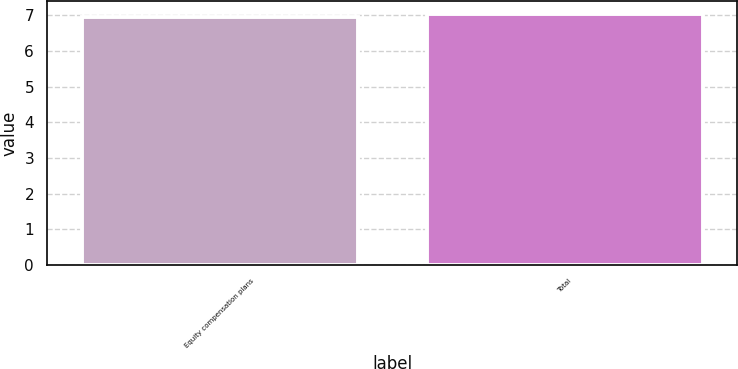Convert chart to OTSL. <chart><loc_0><loc_0><loc_500><loc_500><bar_chart><fcel>Equity compensation plans<fcel>Total<nl><fcel>6.95<fcel>7.05<nl></chart> 